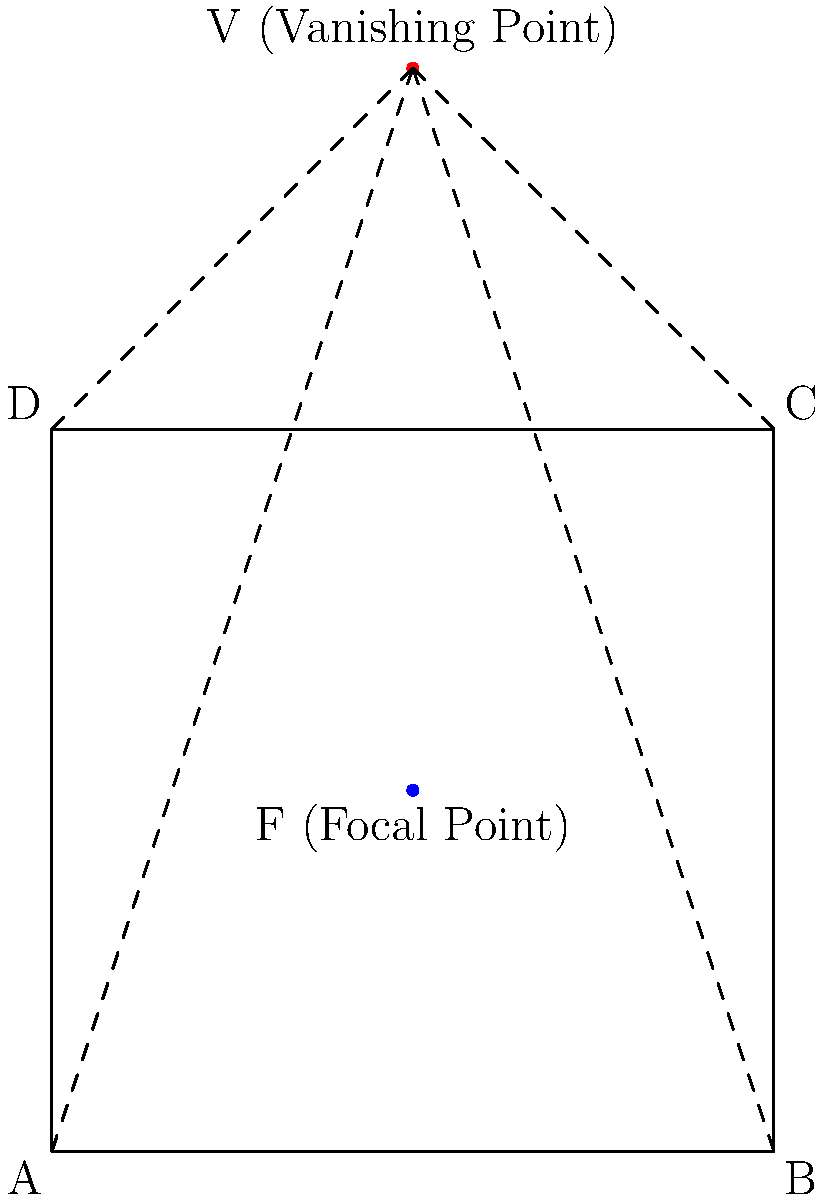In a Renaissance painting of dimensions 100x100 units, the focal point F is located at the center (50, 50). If the vanishing point V is situated 50 units above the top edge of the painting, calculate the angle θ between the line connecting the bottom-left corner (A) to the vanishing point (V) and the bottom edge of the painting (AB). To solve this problem, we'll follow these steps:

1) First, let's identify the coordinates of the relevant points:
   A (0, 0)
   B (100, 0)
   V (50, 150)

2) We need to calculate the angle between AV and AB. We can do this using the arctangent function.

3) To use arctangent, we need the rise and run of line AV:
   Rise = 150 - 0 = 150
   Run = 50 - 0 = 50

4) The angle θ is given by:
   $$θ = \arctan(\frac{\text{Rise}}{\text{Run}})$$

5) Substituting our values:
   $$θ = \arctan(\frac{150}{50})$$

6) Simplify:
   $$θ = \arctan(3)$$

7) Calculate:
   $$θ ≈ 71.57°$$

Therefore, the angle between line AV and the bottom edge of the painting is approximately 71.57 degrees.
Answer: $\arctan(3)$ or approximately 71.57° 